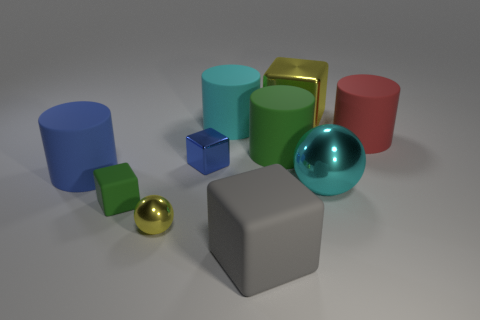The yellow metallic object that is the same shape as the big gray rubber object is what size?
Provide a short and direct response. Large. Does the tiny yellow object have the same shape as the large cyan metallic thing?
Make the answer very short. Yes. Are there fewer blue blocks left of the tiny yellow metal object than metallic cubes in front of the red matte cylinder?
Your answer should be very brief. Yes. There is a small yellow thing; how many big objects are on the right side of it?
Offer a very short reply. 6. Does the tiny metallic object that is on the left side of the blue shiny thing have the same shape as the matte object that is in front of the small rubber cube?
Your response must be concise. No. How many other things are the same color as the big metallic block?
Keep it short and to the point. 1. There is a green object right of the green rubber object in front of the large object that is left of the green block; what is it made of?
Offer a terse response. Rubber. There is a cyan object on the right side of the large block that is behind the large green cylinder; what is its material?
Offer a terse response. Metal. Are there fewer big cyan objects behind the green rubber block than small objects?
Provide a succinct answer. Yes. What shape is the big green thing behind the big shiny sphere?
Provide a short and direct response. Cylinder. 